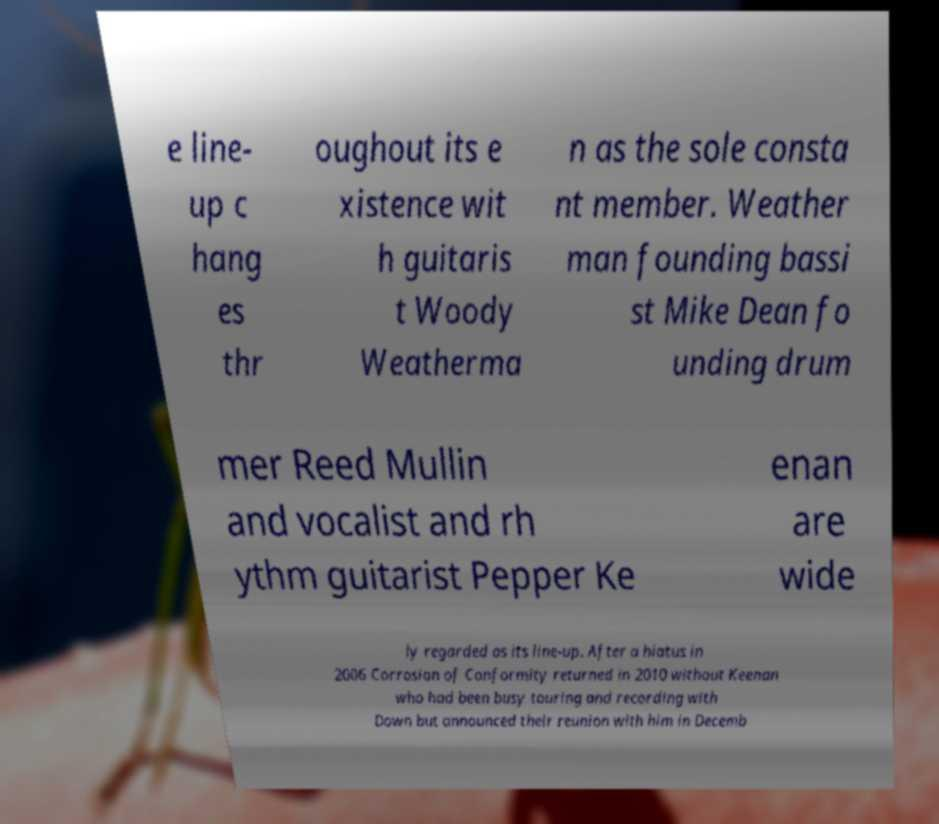For documentation purposes, I need the text within this image transcribed. Could you provide that? e line- up c hang es thr oughout its e xistence wit h guitaris t Woody Weatherma n as the sole consta nt member. Weather man founding bassi st Mike Dean fo unding drum mer Reed Mullin and vocalist and rh ythm guitarist Pepper Ke enan are wide ly regarded as its line-up. After a hiatus in 2006 Corrosion of Conformity returned in 2010 without Keenan who had been busy touring and recording with Down but announced their reunion with him in Decemb 